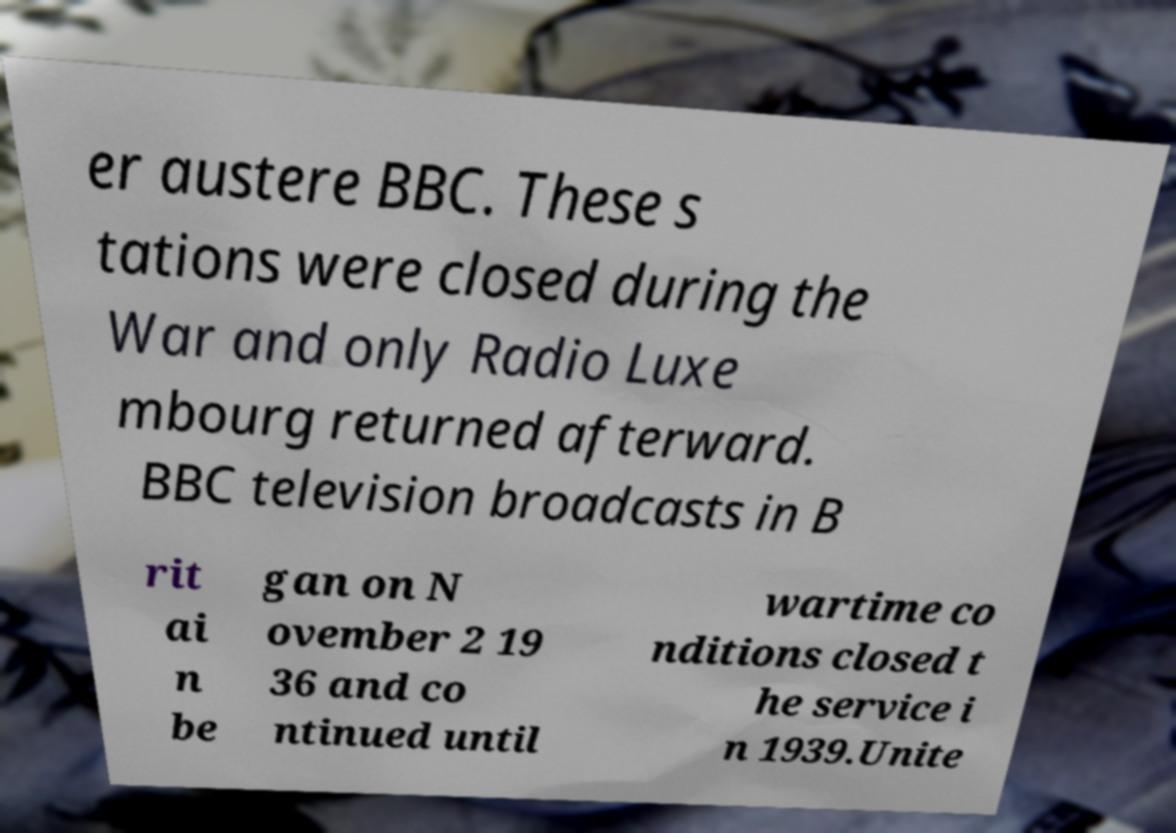There's text embedded in this image that I need extracted. Can you transcribe it verbatim? er austere BBC. These s tations were closed during the War and only Radio Luxe mbourg returned afterward. BBC television broadcasts in B rit ai n be gan on N ovember 2 19 36 and co ntinued until wartime co nditions closed t he service i n 1939.Unite 